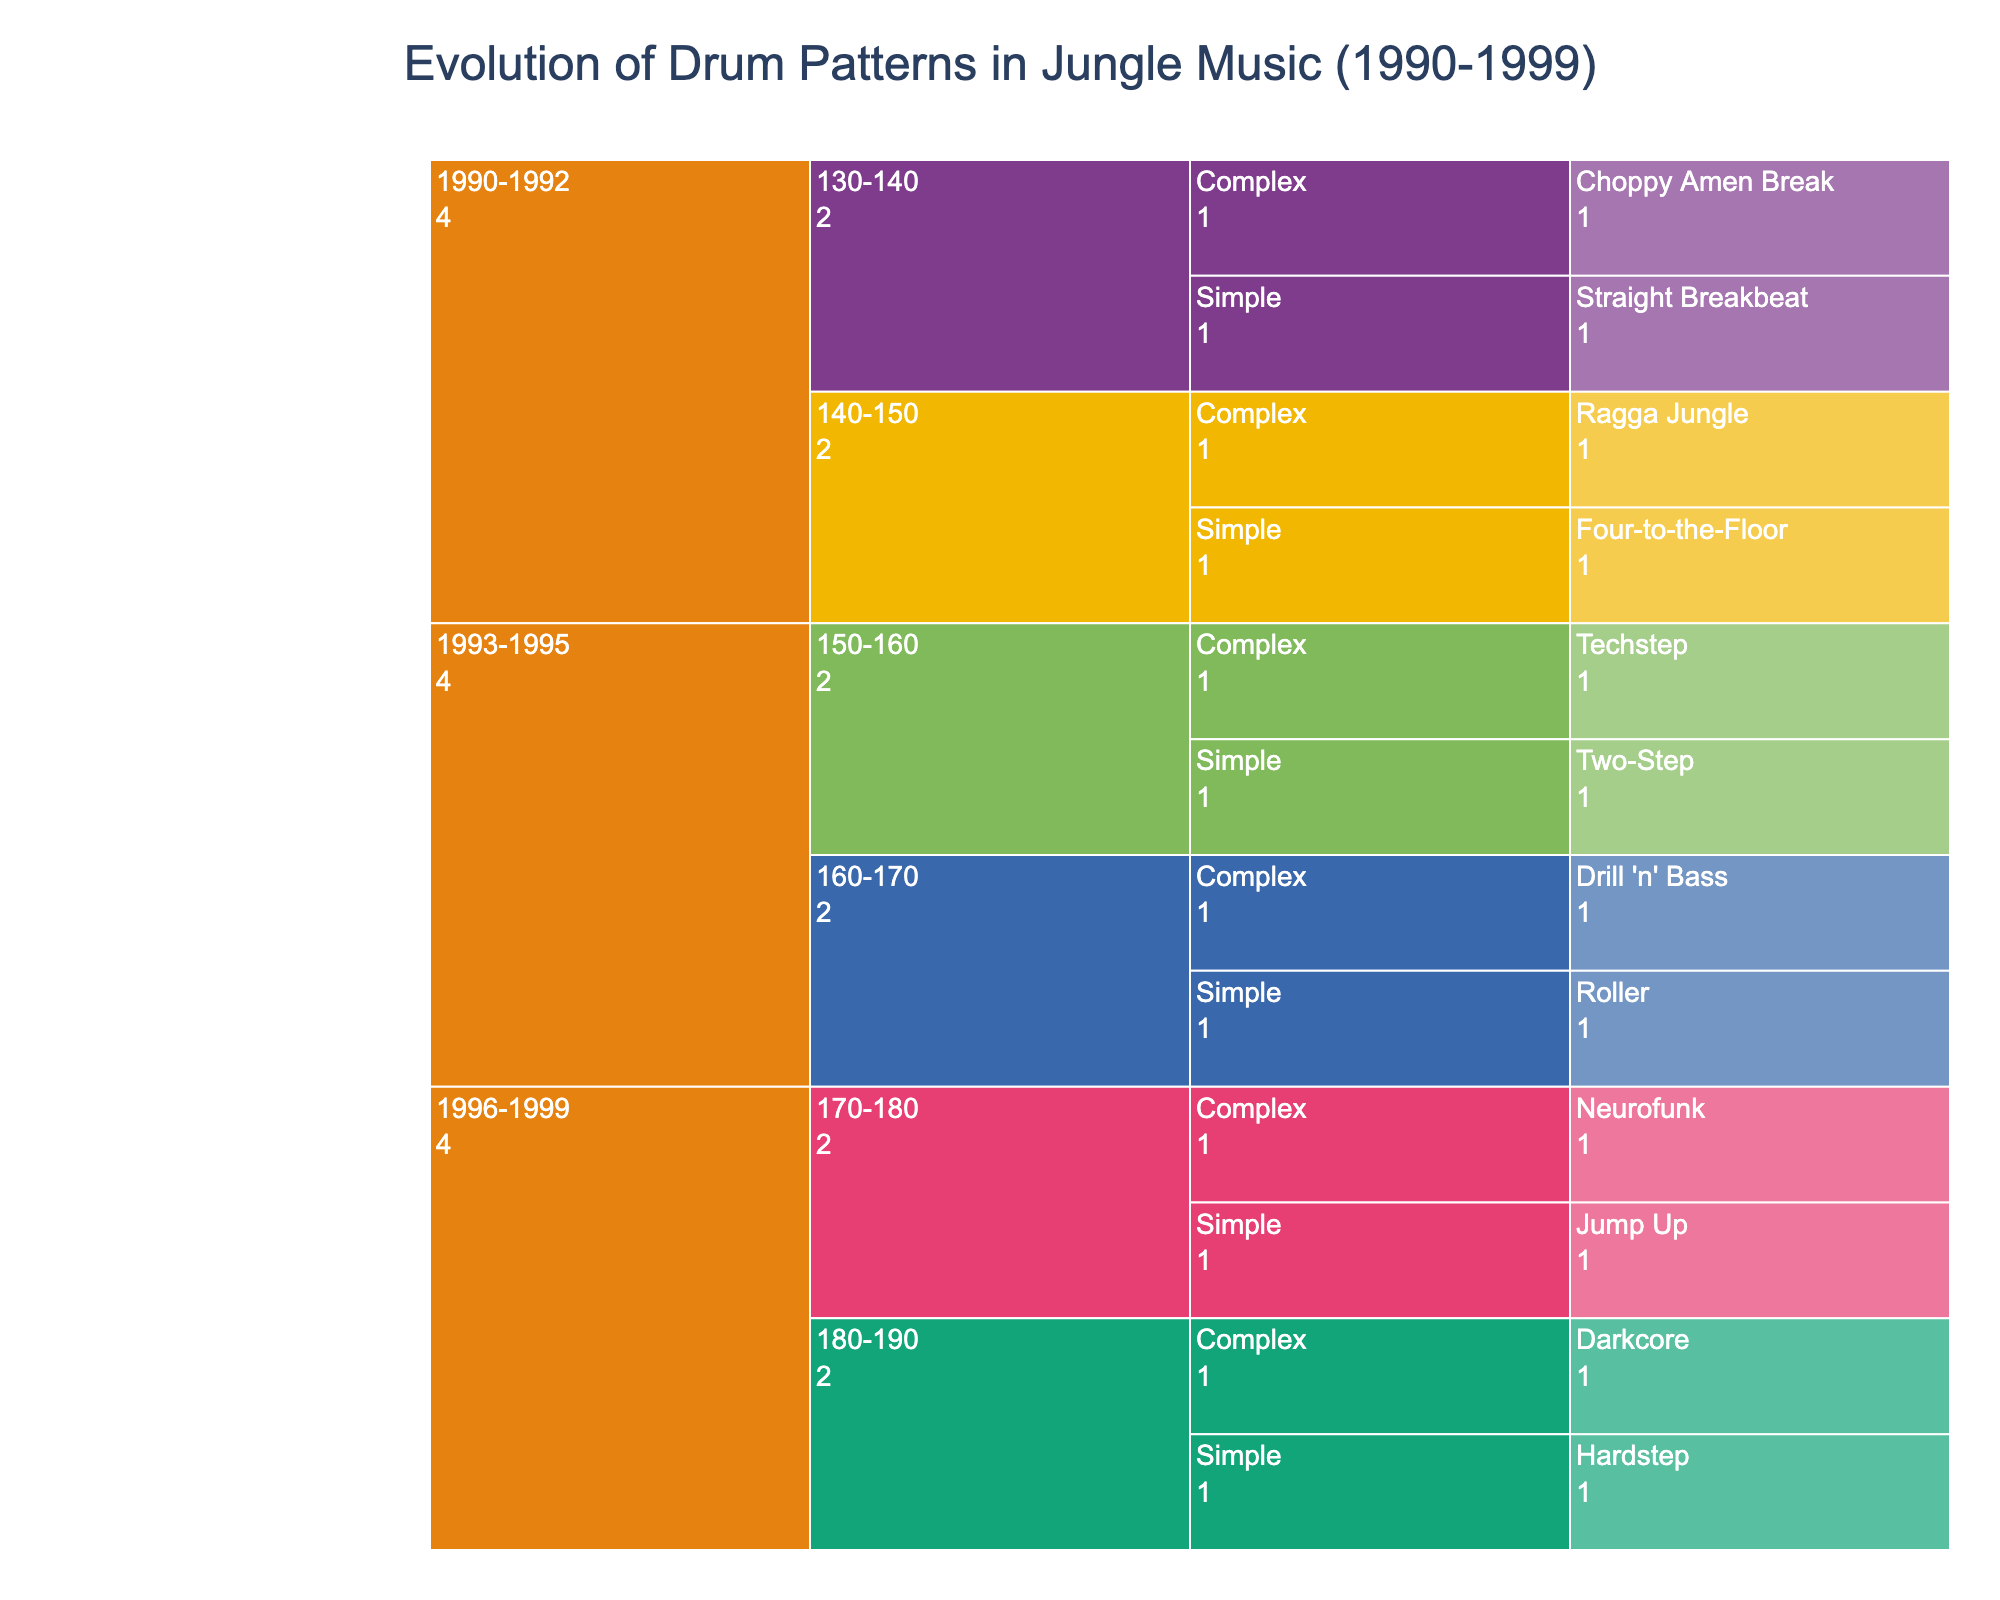What is the title of the icicle chart? The title of the chart is displayed at the top of the figure, typically formatted in larger, bold text.
Answer: Evolution of Drum Patterns in Jungle Music (1990-1999) During which years does the chart show drum patterns evolving the most in complexity? To determine this, compare the number of complex patterns listed for each time period in the chart. There are the most complex patterns listed during 1993-1995 and 1996-1999 in comparison to 1990-1992.
Answer: 1993-1995 and 1996-1999 How many simple drum patterns are categorized under 140-150 BPM? Locate the 140-150 BPM category in the icicle chart and count the number of patterns with 'Simple' complexity listed underneath.
Answer: 1 Which BPM range has patterns labeled as "Darkcore"? Find the pattern labeled "Darkcore" and trace its hierarchy back to its parent BPM range category.
Answer: 180-190 Compare the number of drum patterns with 'Complex' complexity versus 'Simple' complexity in the range 170-180 BPM. Which is higher? Locate the range 170-180 BPM in the chart and count the number of patterns under 'Complex' and 'Simple' respectively. Compare the counts to determine which is higher. Simple has 1 pattern and Complex has 1 pattern, so they are equal.
Answer: Equal What pattern is considered complex in the range of 150-160 BPM between 1993 and 1995? Look under the 1993-1995 years, find the 150-160 BPM range, and then identify which pattern is marked as having 'Complex' complexity.
Answer: Techstep How many drum patterns are listed from the 1990 to 1992 period? Look at the 1990-1992 section in the chart and count all the patterns listed under various BPM ranges and complexities.
Answer: 4 Which year range includes the "Neurofunk" pattern and what is its BPM range? Locate the "Neurofunk" pattern in the chart and track its hierarchical path to identify both the year range and BPM range it's listed under.
Answer: 1996-1999, 170-180 BPM What is the most common BPM range for simple drum patterns from 1996-1999? Look at the section for 1996-1999 and check which BPM range has the highest count of simple drum patterns. You will see there are 1 each in 170-180 and 180-190 BPM.
Answer: 170-180 BPM and 180-190 BPM (Tie) Identify a pattern from the 1993-1995 period with a 'Simple' complexity and a BPM range of 160-170. Navigate to the 1993-1995 years and locate the patterns under the 160-170 BPM range and 'Simple' complexity.
Answer: Roller 